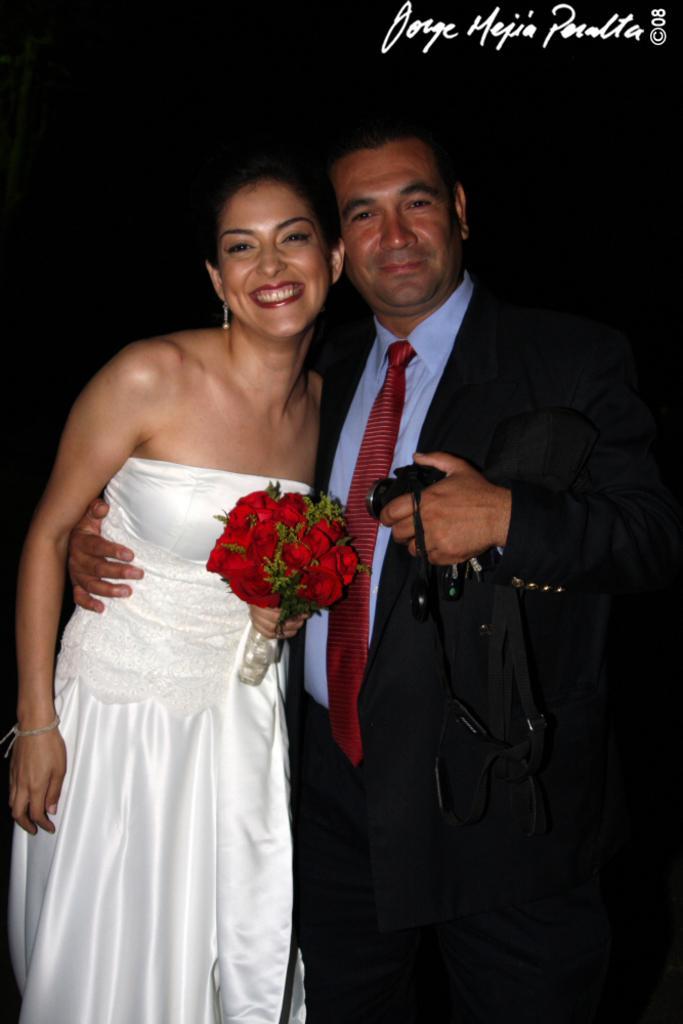In one or two sentences, can you explain what this image depicts? In the picture we can see a man and a woman standing together and smiling, woman is in a white dress and holding some red color flowers and man is holding a camera and he is in blazer, tie and shirt and behind them we can see dark. 